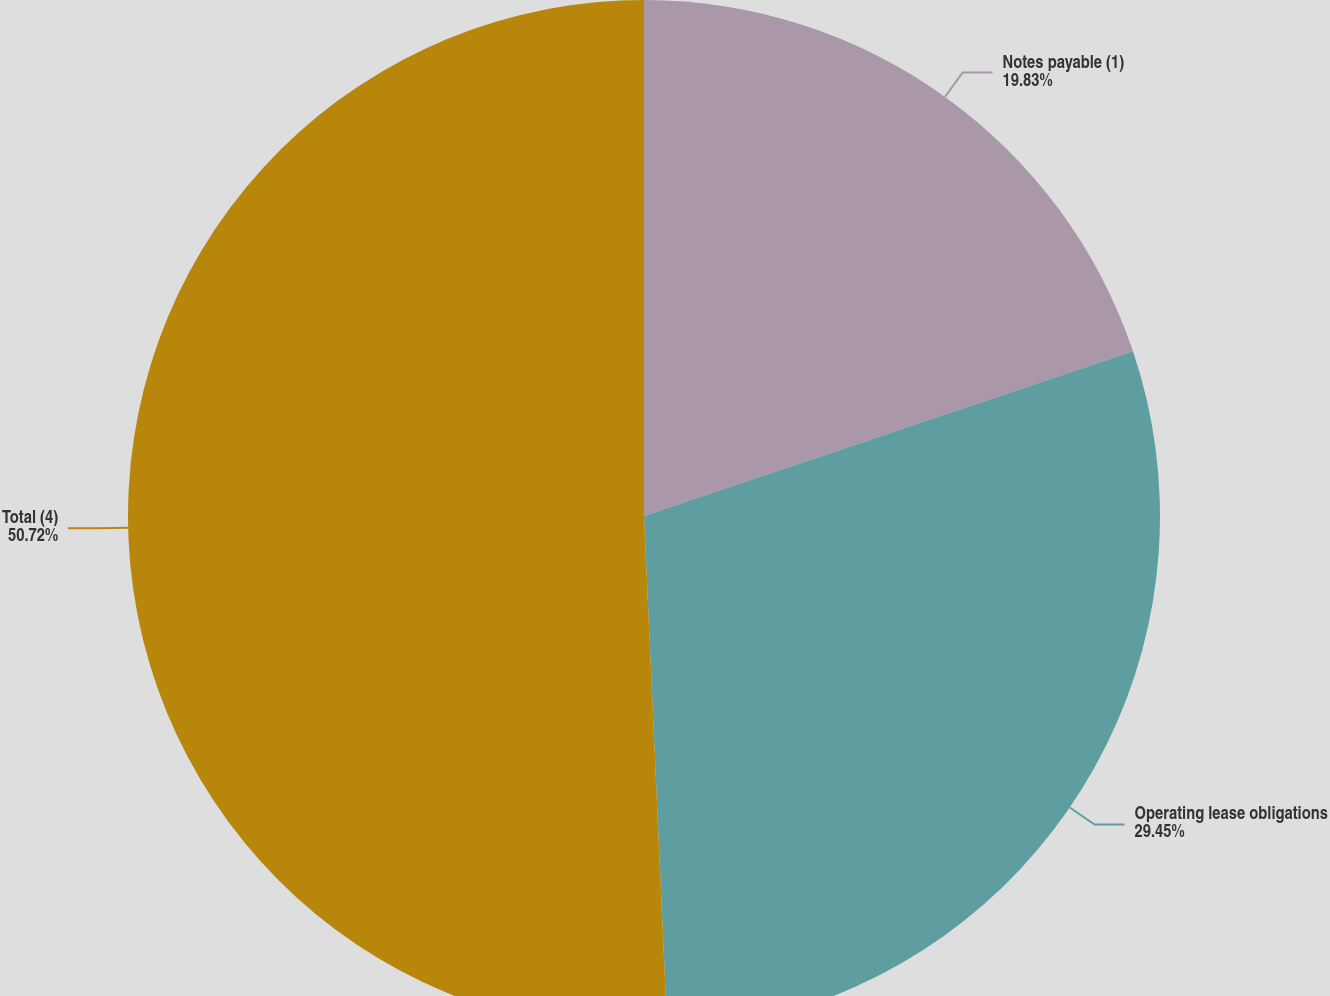<chart> <loc_0><loc_0><loc_500><loc_500><pie_chart><fcel>Notes payable (1)<fcel>Operating lease obligations<fcel>Total (4)<nl><fcel>19.83%<fcel>29.45%<fcel>50.72%<nl></chart> 